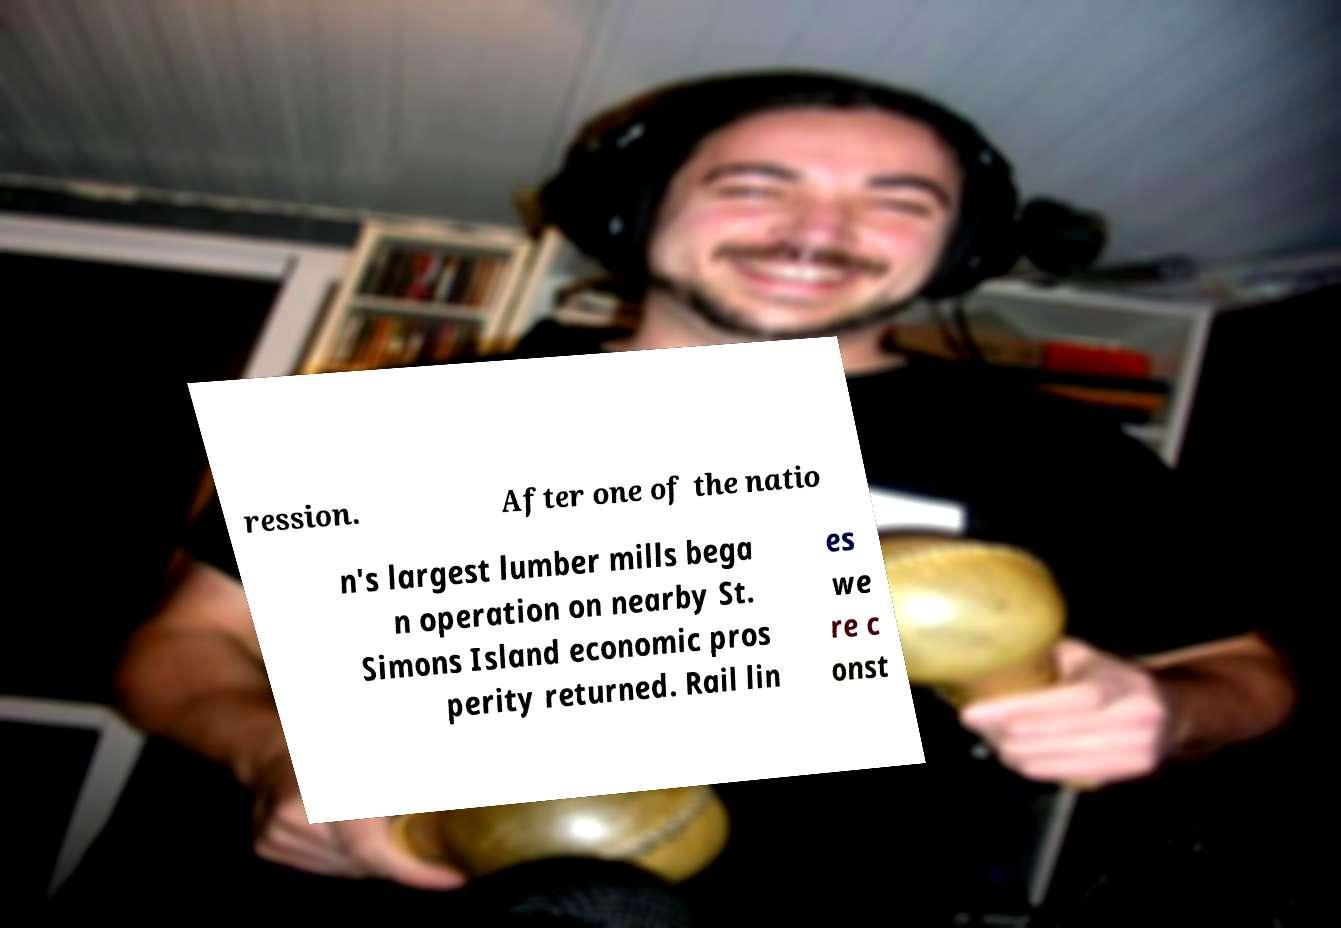I need the written content from this picture converted into text. Can you do that? ression. After one of the natio n's largest lumber mills bega n operation on nearby St. Simons Island economic pros perity returned. Rail lin es we re c onst 